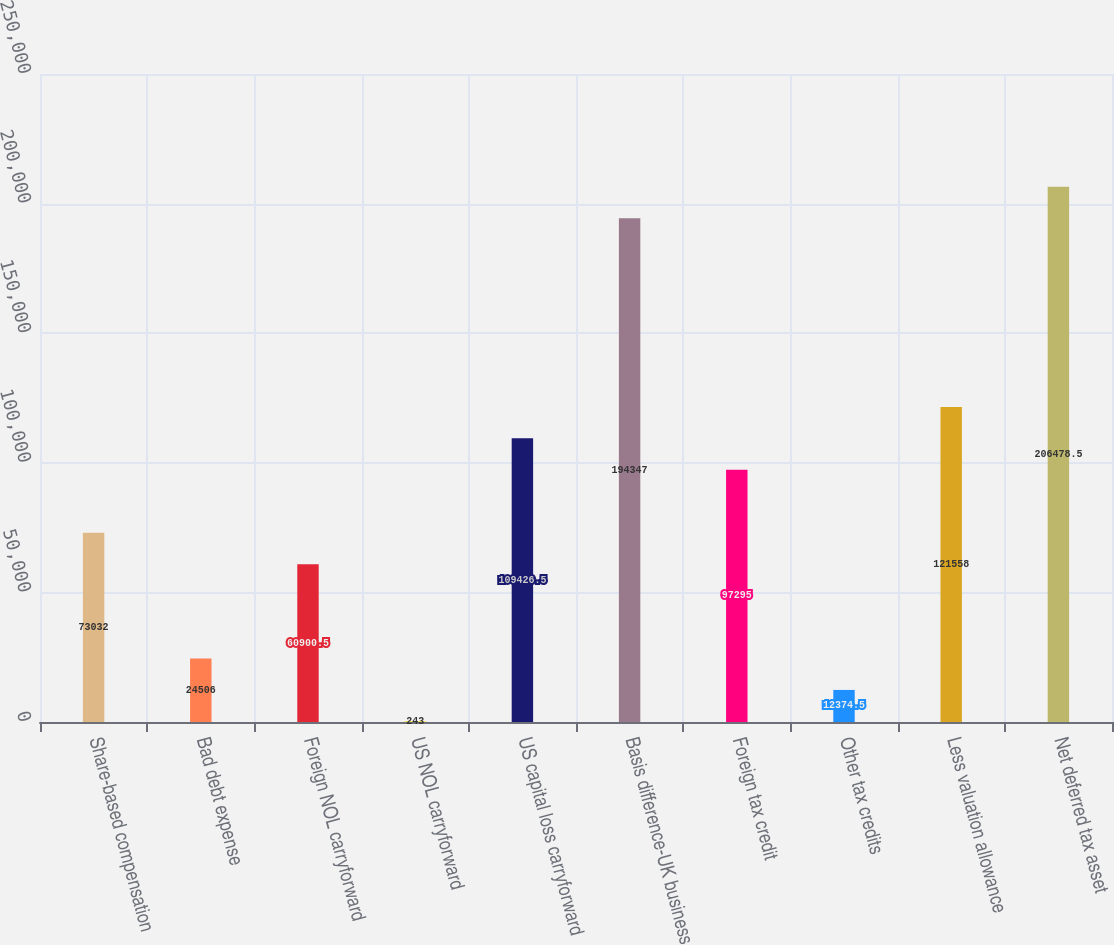Convert chart to OTSL. <chart><loc_0><loc_0><loc_500><loc_500><bar_chart><fcel>Share-based compensation<fcel>Bad debt expense<fcel>Foreign NOL carryforward<fcel>US NOL carryforward<fcel>US capital loss carryforward<fcel>Basis difference-UK business<fcel>Foreign tax credit<fcel>Other tax credits<fcel>Less valuation allowance<fcel>Net deferred tax asset<nl><fcel>73032<fcel>24506<fcel>60900.5<fcel>243<fcel>109426<fcel>194347<fcel>97295<fcel>12374.5<fcel>121558<fcel>206478<nl></chart> 